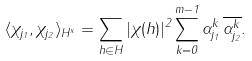<formula> <loc_0><loc_0><loc_500><loc_500>\langle \chi _ { j _ { 1 } } , \chi _ { j _ { 2 } } \rangle _ { H ^ { x } } = \sum _ { h \in H } | \chi ( h ) | ^ { 2 } \sum _ { k = 0 } ^ { m - 1 } \alpha _ { j _ { 1 } } ^ { k } \, \overline { \alpha _ { j _ { 2 } } ^ { k } } .</formula> 